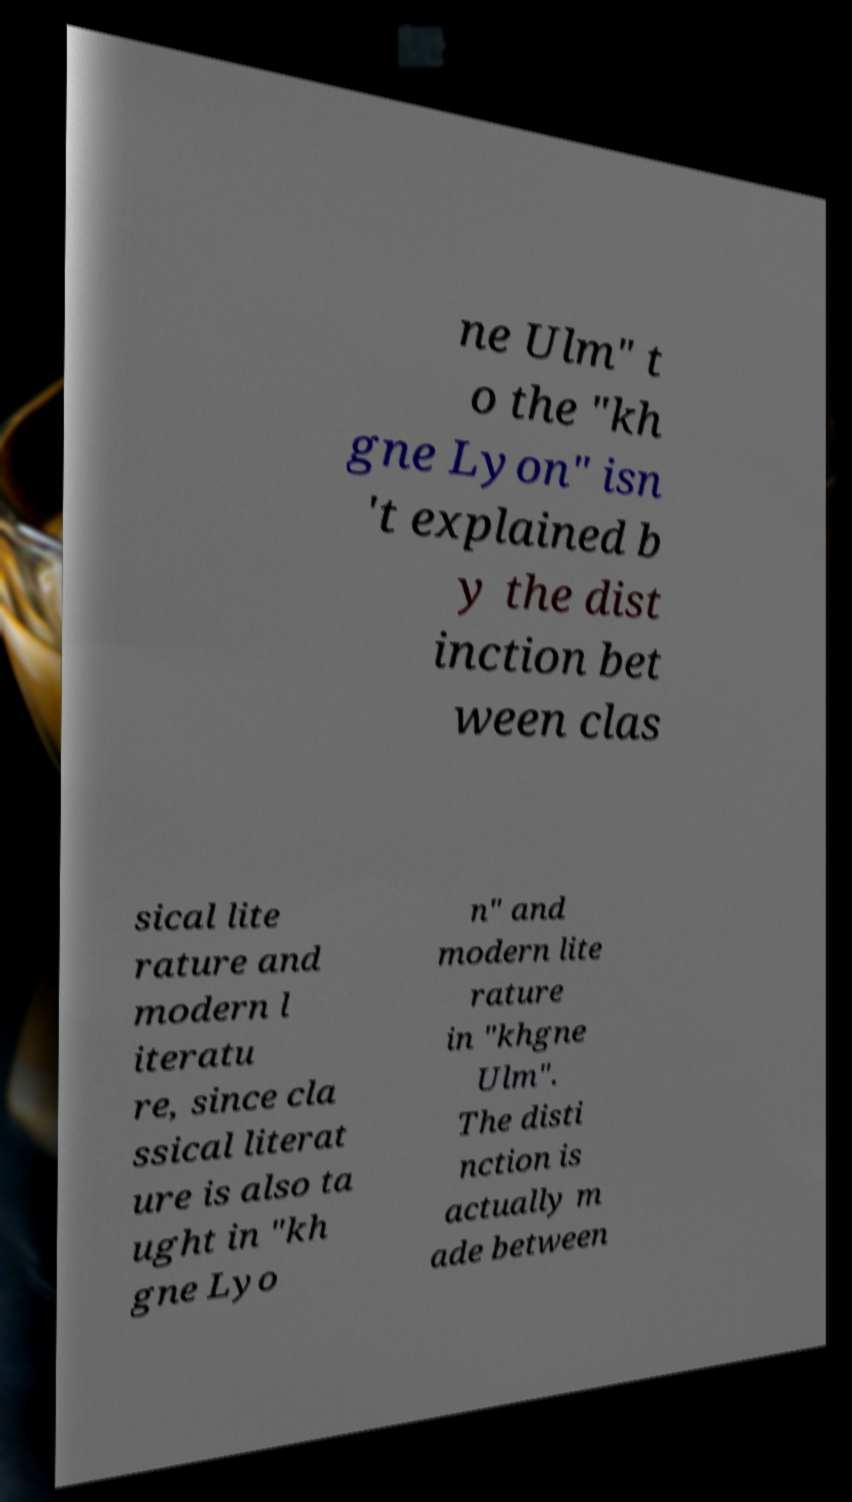I need the written content from this picture converted into text. Can you do that? ne Ulm" t o the "kh gne Lyon" isn 't explained b y the dist inction bet ween clas sical lite rature and modern l iteratu re, since cla ssical literat ure is also ta ught in "kh gne Lyo n" and modern lite rature in "khgne Ulm". The disti nction is actually m ade between 